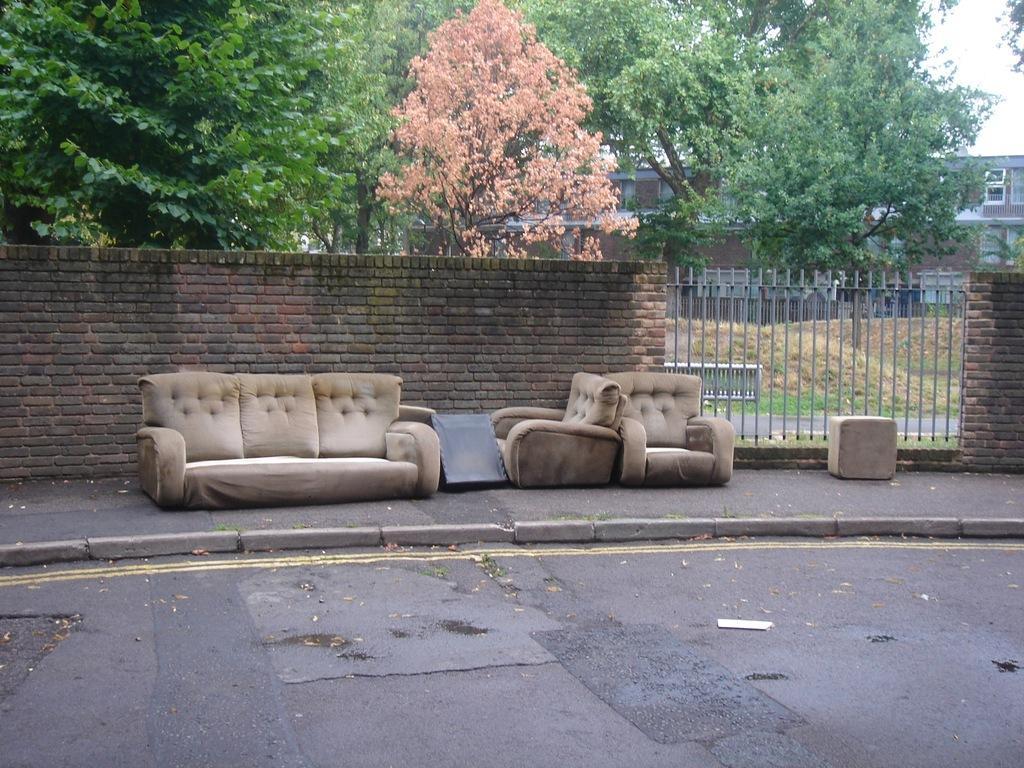Describe this image in one or two sentences. The image is outside of the city. In the image we can see a couch on footpath, in background there are some buildings,window,trees and grass at bottom and sky is on top. On left side we can also see a brick wall. 